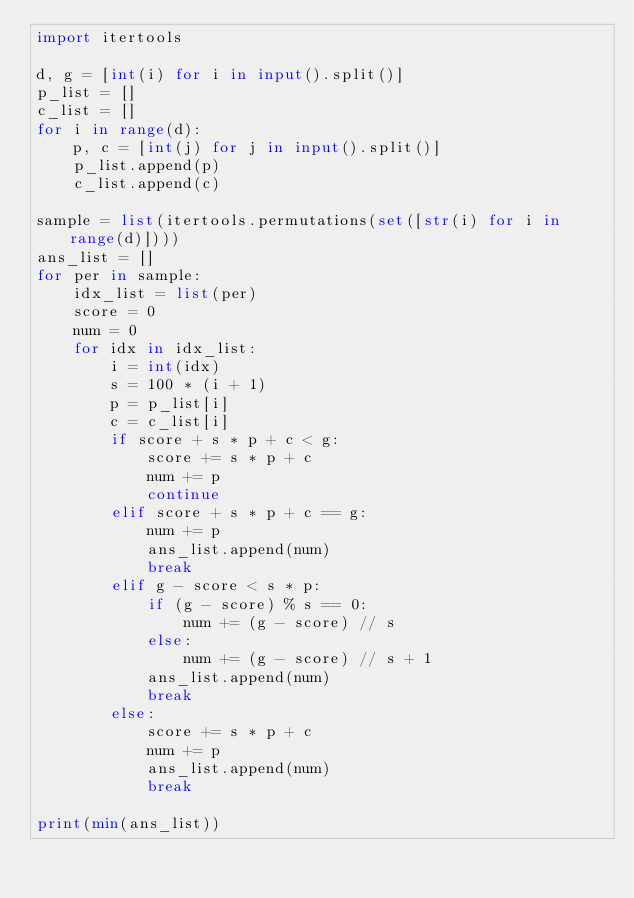Convert code to text. <code><loc_0><loc_0><loc_500><loc_500><_Python_>import itertools

d, g = [int(i) for i in input().split()]
p_list = []
c_list = []
for i in range(d):
    p, c = [int(j) for j in input().split()]
    p_list.append(p)
    c_list.append(c)

sample = list(itertools.permutations(set([str(i) for i in range(d)])))
ans_list = []
for per in sample:
    idx_list = list(per)
    score = 0
    num = 0
    for idx in idx_list:
        i = int(idx)
        s = 100 * (i + 1)
        p = p_list[i]
        c = c_list[i]
        if score + s * p + c < g:
            score += s * p + c
            num += p
            continue
        elif score + s * p + c == g:
            num += p
            ans_list.append(num)
            break
        elif g - score < s * p:
            if (g - score) % s == 0:
                num += (g - score) // s
            else:
                num += (g - score) // s + 1
            ans_list.append(num)
            break
        else:
            score += s * p + c
            num += p
            ans_list.append(num)
            break

print(min(ans_list))</code> 